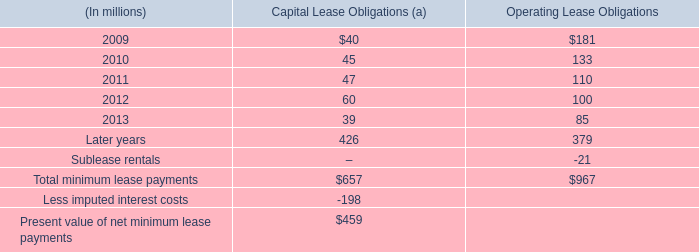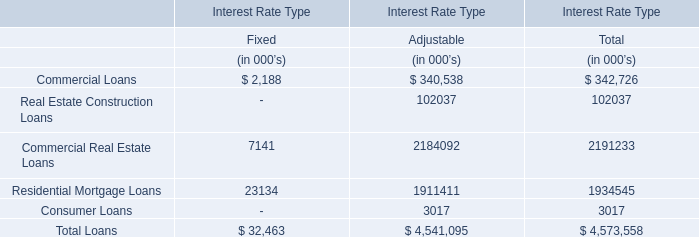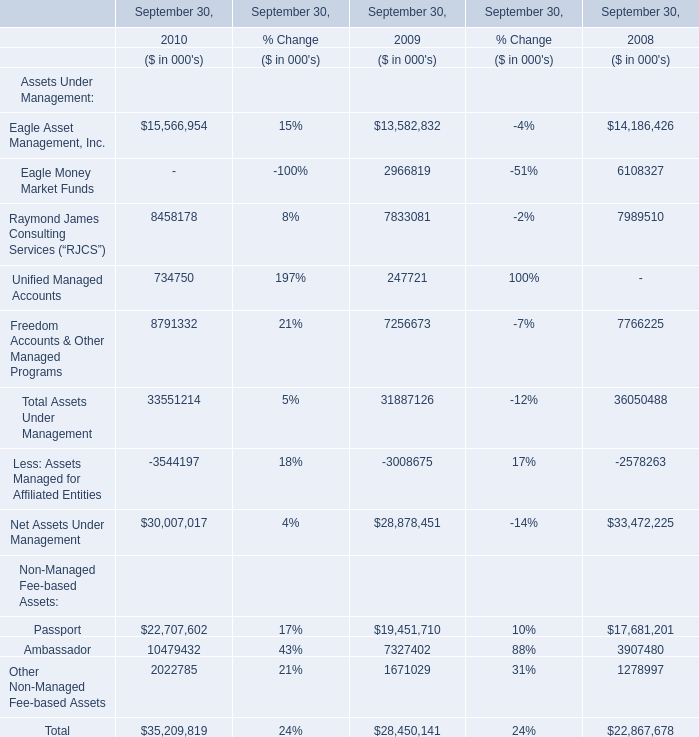What is the percentage of Eagle Asset Management, Inc. in relation to the total in 2009 ? 
Computations: (13582832 / (28878451 + 28450141))
Answer: 0.23693. 